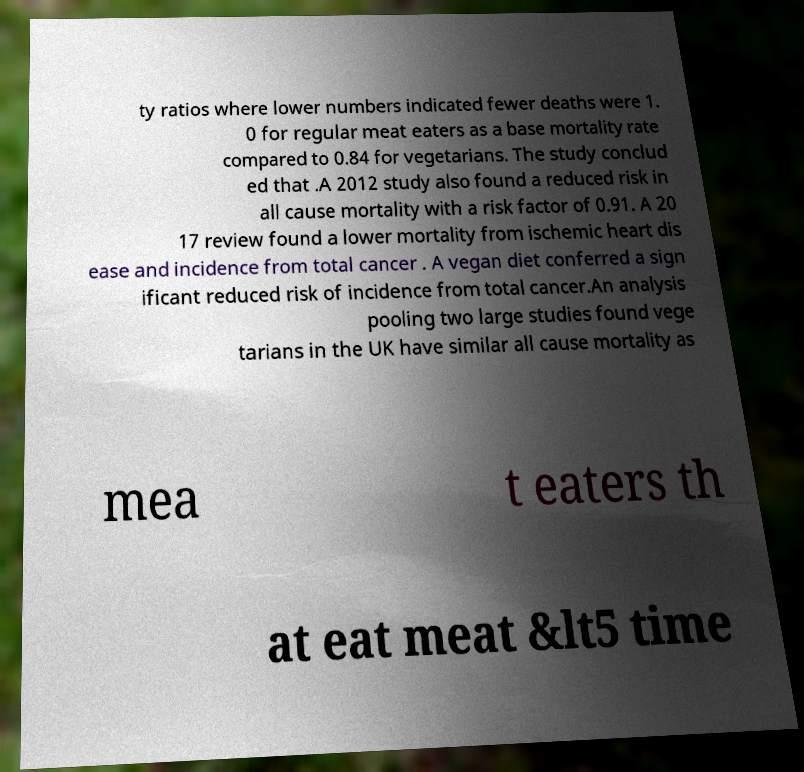What messages or text are displayed in this image? I need them in a readable, typed format. ty ratios where lower numbers indicated fewer deaths were 1. 0 for regular meat eaters as a base mortality rate compared to 0.84 for vegetarians. The study conclud ed that .A 2012 study also found a reduced risk in all cause mortality with a risk factor of 0.91. A 20 17 review found a lower mortality from ischemic heart dis ease and incidence from total cancer . A vegan diet conferred a sign ificant reduced risk of incidence from total cancer.An analysis pooling two large studies found vege tarians in the UK have similar all cause mortality as mea t eaters th at eat meat &lt5 time 